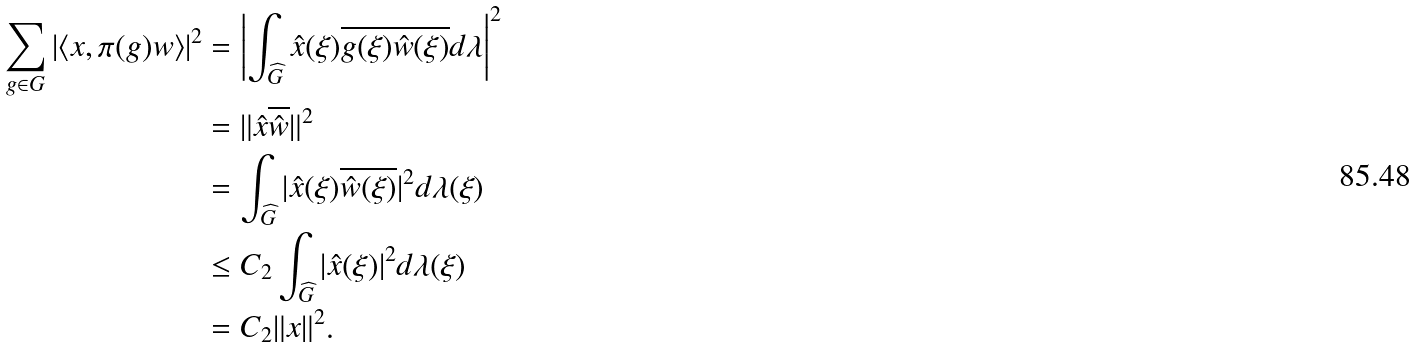Convert formula to latex. <formula><loc_0><loc_0><loc_500><loc_500>\sum _ { g \in G } | \langle x , \pi ( g ) w \rangle | ^ { 2 } & = \left | \int _ { \widehat { G } } \hat { x } ( \xi ) \overline { g ( \xi ) \hat { w } ( \xi ) } d \lambda \right | ^ { 2 } \\ & = \| \hat { x } \overline { \hat { w } } \| ^ { 2 } \\ & = \int _ { \widehat { G } } | \hat { x } ( \xi ) \overline { \hat { w } ( \xi ) } | ^ { 2 } d \lambda ( \xi ) \\ & \leq C _ { 2 } \int _ { \widehat { G } } | \hat { x } ( \xi ) | ^ { 2 } d \lambda ( \xi ) \\ & = C _ { 2 } \| x \| ^ { 2 } .</formula> 